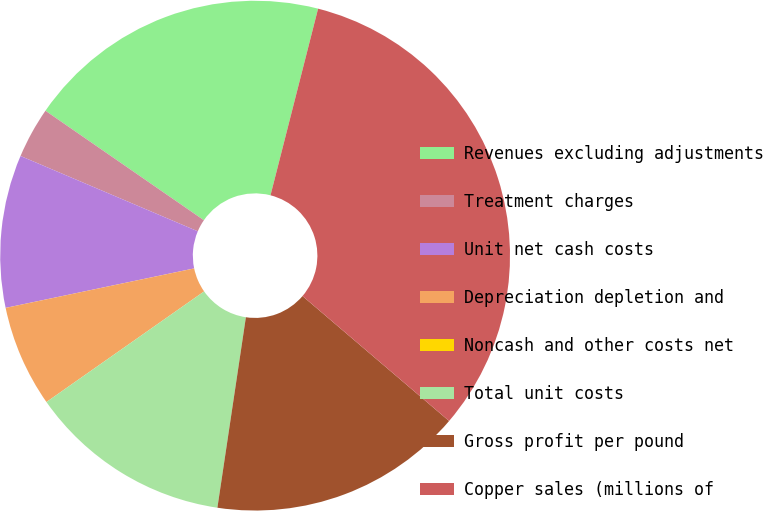<chart> <loc_0><loc_0><loc_500><loc_500><pie_chart><fcel>Revenues excluding adjustments<fcel>Treatment charges<fcel>Unit net cash costs<fcel>Depreciation depletion and<fcel>Noncash and other costs net<fcel>Total unit costs<fcel>Gross profit per pound<fcel>Copper sales (millions of<nl><fcel>19.35%<fcel>3.23%<fcel>9.68%<fcel>6.45%<fcel>0.0%<fcel>12.9%<fcel>16.13%<fcel>32.26%<nl></chart> 